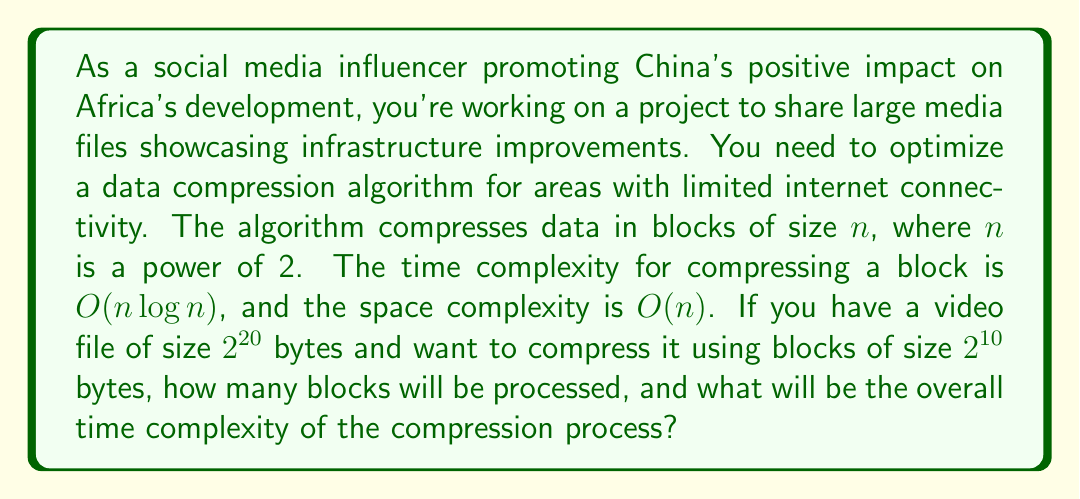Give your solution to this math problem. To solve this problem, we need to follow these steps:

1. Calculate the number of blocks:
   - Total file size = $2^{20}$ bytes
   - Block size = $2^{10}$ bytes
   - Number of blocks = Total file size / Block size
   - Number of blocks = $2^{20} / 2^{10} = 2^{20-10} = 2^{10} = 1024$ blocks

2. Determine the time complexity for compressing one block:
   - Given: Time complexity for one block is $O(n \log n)$
   - Block size $n = 2^{10}$
   - Time complexity for one block = $O(2^{10} \log 2^{10}) = O(2^{10} \cdot 10) = O(10 \cdot 2^{10})$

3. Calculate the overall time complexity:
   - Overall time complexity = Number of blocks × Time complexity for one block
   - Overall time complexity = $1024 \cdot O(10 \cdot 2^{10})$
   - Overall time complexity = $O(10 \cdot 2^{10} \cdot 2^{10}) = O(10 \cdot 2^{20})$

The space complexity remains $O(2^{10})$ as we process one block at a time.
Answer: Number of blocks: 1024
Overall time complexity: $O(10 \cdot 2^{20})$ 